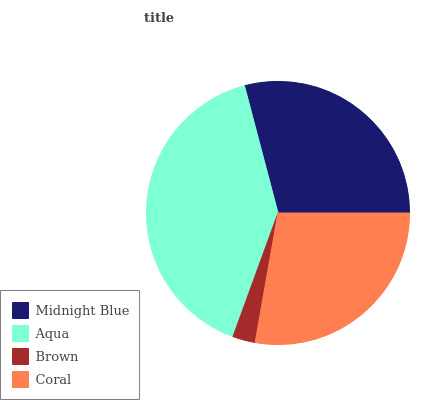Is Brown the minimum?
Answer yes or no. Yes. Is Aqua the maximum?
Answer yes or no. Yes. Is Aqua the minimum?
Answer yes or no. No. Is Brown the maximum?
Answer yes or no. No. Is Aqua greater than Brown?
Answer yes or no. Yes. Is Brown less than Aqua?
Answer yes or no. Yes. Is Brown greater than Aqua?
Answer yes or no. No. Is Aqua less than Brown?
Answer yes or no. No. Is Midnight Blue the high median?
Answer yes or no. Yes. Is Coral the low median?
Answer yes or no. Yes. Is Coral the high median?
Answer yes or no. No. Is Midnight Blue the low median?
Answer yes or no. No. 